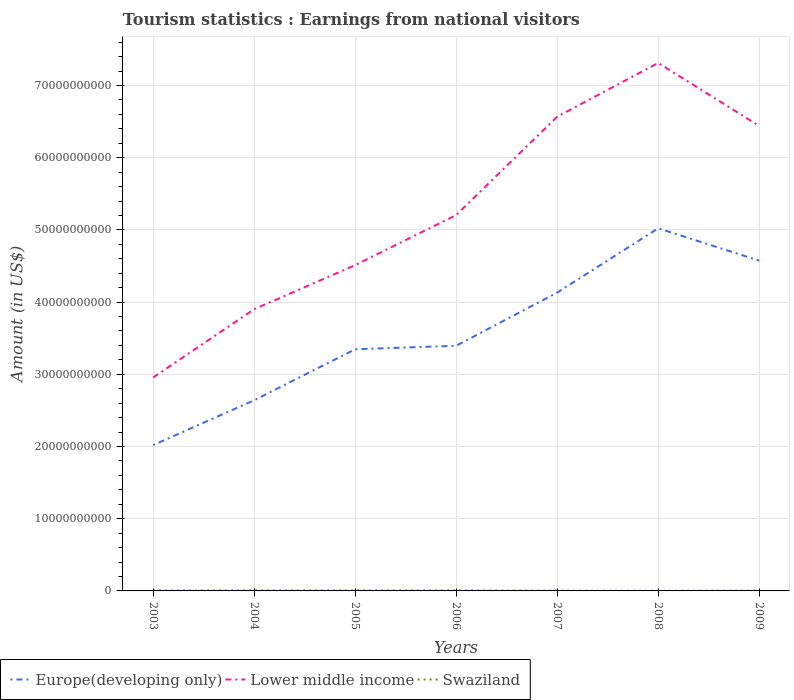Is the number of lines equal to the number of legend labels?
Ensure brevity in your answer.  Yes. Across all years, what is the maximum earnings from national visitors in Lower middle income?
Your answer should be very brief. 2.96e+1. What is the total earnings from national visitors in Lower middle income in the graph?
Offer a terse response. -2.67e+1. What is the difference between the highest and the second highest earnings from national visitors in Swaziland?
Give a very brief answer. 5.10e+07. What is the difference between the highest and the lowest earnings from national visitors in Lower middle income?
Provide a short and direct response. 3. Is the earnings from national visitors in Swaziland strictly greater than the earnings from national visitors in Europe(developing only) over the years?
Your answer should be very brief. Yes. How many years are there in the graph?
Provide a short and direct response. 7. What is the difference between two consecutive major ticks on the Y-axis?
Your response must be concise. 1.00e+1. Are the values on the major ticks of Y-axis written in scientific E-notation?
Your answer should be compact. No. How are the legend labels stacked?
Give a very brief answer. Horizontal. What is the title of the graph?
Provide a succinct answer. Tourism statistics : Earnings from national visitors. What is the label or title of the Y-axis?
Offer a terse response. Amount (in US$). What is the Amount (in US$) in Europe(developing only) in 2003?
Provide a succinct answer. 2.02e+1. What is the Amount (in US$) in Lower middle income in 2003?
Give a very brief answer. 2.96e+1. What is the Amount (in US$) in Swaziland in 2003?
Ensure brevity in your answer.  7.00e+07. What is the Amount (in US$) in Europe(developing only) in 2004?
Keep it short and to the point. 2.64e+1. What is the Amount (in US$) of Lower middle income in 2004?
Provide a short and direct response. 3.90e+1. What is the Amount (in US$) of Swaziland in 2004?
Ensure brevity in your answer.  7.51e+07. What is the Amount (in US$) of Europe(developing only) in 2005?
Make the answer very short. 3.35e+1. What is the Amount (in US$) of Lower middle income in 2005?
Keep it short and to the point. 4.51e+1. What is the Amount (in US$) of Swaziland in 2005?
Your response must be concise. 7.73e+07. What is the Amount (in US$) in Europe(developing only) in 2006?
Offer a very short reply. 3.40e+1. What is the Amount (in US$) of Lower middle income in 2006?
Ensure brevity in your answer.  5.21e+1. What is the Amount (in US$) in Swaziland in 2006?
Keep it short and to the point. 7.51e+07. What is the Amount (in US$) of Europe(developing only) in 2007?
Make the answer very short. 4.13e+1. What is the Amount (in US$) of Lower middle income in 2007?
Ensure brevity in your answer.  6.57e+1. What is the Amount (in US$) of Swaziland in 2007?
Offer a very short reply. 3.22e+07. What is the Amount (in US$) of Europe(developing only) in 2008?
Offer a terse response. 5.02e+1. What is the Amount (in US$) of Lower middle income in 2008?
Provide a short and direct response. 7.31e+1. What is the Amount (in US$) of Swaziland in 2008?
Provide a short and direct response. 2.63e+07. What is the Amount (in US$) in Europe(developing only) in 2009?
Keep it short and to the point. 4.57e+1. What is the Amount (in US$) of Lower middle income in 2009?
Offer a very short reply. 6.44e+1. What is the Amount (in US$) in Swaziland in 2009?
Your answer should be very brief. 4.01e+07. Across all years, what is the maximum Amount (in US$) in Europe(developing only)?
Ensure brevity in your answer.  5.02e+1. Across all years, what is the maximum Amount (in US$) of Lower middle income?
Ensure brevity in your answer.  7.31e+1. Across all years, what is the maximum Amount (in US$) in Swaziland?
Your response must be concise. 7.73e+07. Across all years, what is the minimum Amount (in US$) in Europe(developing only)?
Your answer should be very brief. 2.02e+1. Across all years, what is the minimum Amount (in US$) of Lower middle income?
Give a very brief answer. 2.96e+1. Across all years, what is the minimum Amount (in US$) in Swaziland?
Your answer should be very brief. 2.63e+07. What is the total Amount (in US$) of Europe(developing only) in the graph?
Make the answer very short. 2.51e+11. What is the total Amount (in US$) in Lower middle income in the graph?
Provide a short and direct response. 3.69e+11. What is the total Amount (in US$) of Swaziland in the graph?
Offer a very short reply. 3.96e+08. What is the difference between the Amount (in US$) of Europe(developing only) in 2003 and that in 2004?
Offer a very short reply. -6.21e+09. What is the difference between the Amount (in US$) in Lower middle income in 2003 and that in 2004?
Keep it short and to the point. -9.46e+09. What is the difference between the Amount (in US$) in Swaziland in 2003 and that in 2004?
Your answer should be compact. -5.06e+06. What is the difference between the Amount (in US$) of Europe(developing only) in 2003 and that in 2005?
Ensure brevity in your answer.  -1.33e+1. What is the difference between the Amount (in US$) of Lower middle income in 2003 and that in 2005?
Ensure brevity in your answer.  -1.56e+1. What is the difference between the Amount (in US$) in Swaziland in 2003 and that in 2005?
Offer a terse response. -7.26e+06. What is the difference between the Amount (in US$) in Europe(developing only) in 2003 and that in 2006?
Provide a succinct answer. -1.38e+1. What is the difference between the Amount (in US$) of Lower middle income in 2003 and that in 2006?
Provide a short and direct response. -2.25e+1. What is the difference between the Amount (in US$) in Swaziland in 2003 and that in 2006?
Make the answer very short. -5.06e+06. What is the difference between the Amount (in US$) of Europe(developing only) in 2003 and that in 2007?
Provide a short and direct response. -2.11e+1. What is the difference between the Amount (in US$) in Lower middle income in 2003 and that in 2007?
Your response must be concise. -3.61e+1. What is the difference between the Amount (in US$) in Swaziland in 2003 and that in 2007?
Your answer should be very brief. 3.78e+07. What is the difference between the Amount (in US$) of Europe(developing only) in 2003 and that in 2008?
Your response must be concise. -3.00e+1. What is the difference between the Amount (in US$) of Lower middle income in 2003 and that in 2008?
Your answer should be compact. -4.36e+1. What is the difference between the Amount (in US$) of Swaziland in 2003 and that in 2008?
Your answer should be very brief. 4.37e+07. What is the difference between the Amount (in US$) in Europe(developing only) in 2003 and that in 2009?
Keep it short and to the point. -2.55e+1. What is the difference between the Amount (in US$) of Lower middle income in 2003 and that in 2009?
Your response must be concise. -3.48e+1. What is the difference between the Amount (in US$) in Swaziland in 2003 and that in 2009?
Ensure brevity in your answer.  2.99e+07. What is the difference between the Amount (in US$) of Europe(developing only) in 2004 and that in 2005?
Offer a very short reply. -7.06e+09. What is the difference between the Amount (in US$) in Lower middle income in 2004 and that in 2005?
Offer a terse response. -6.11e+09. What is the difference between the Amount (in US$) of Swaziland in 2004 and that in 2005?
Provide a succinct answer. -2.20e+06. What is the difference between the Amount (in US$) of Europe(developing only) in 2004 and that in 2006?
Offer a terse response. -7.55e+09. What is the difference between the Amount (in US$) of Lower middle income in 2004 and that in 2006?
Your answer should be very brief. -1.30e+1. What is the difference between the Amount (in US$) in Europe(developing only) in 2004 and that in 2007?
Your response must be concise. -1.49e+1. What is the difference between the Amount (in US$) in Lower middle income in 2004 and that in 2007?
Your response must be concise. -2.67e+1. What is the difference between the Amount (in US$) of Swaziland in 2004 and that in 2007?
Provide a short and direct response. 4.29e+07. What is the difference between the Amount (in US$) of Europe(developing only) in 2004 and that in 2008?
Give a very brief answer. -2.38e+1. What is the difference between the Amount (in US$) of Lower middle income in 2004 and that in 2008?
Make the answer very short. -3.41e+1. What is the difference between the Amount (in US$) of Swaziland in 2004 and that in 2008?
Give a very brief answer. 4.88e+07. What is the difference between the Amount (in US$) in Europe(developing only) in 2004 and that in 2009?
Offer a terse response. -1.93e+1. What is the difference between the Amount (in US$) in Lower middle income in 2004 and that in 2009?
Your answer should be compact. -2.54e+1. What is the difference between the Amount (in US$) of Swaziland in 2004 and that in 2009?
Your answer should be very brief. 3.50e+07. What is the difference between the Amount (in US$) in Europe(developing only) in 2005 and that in 2006?
Ensure brevity in your answer.  -4.89e+08. What is the difference between the Amount (in US$) in Lower middle income in 2005 and that in 2006?
Provide a short and direct response. -6.93e+09. What is the difference between the Amount (in US$) of Swaziland in 2005 and that in 2006?
Provide a succinct answer. 2.20e+06. What is the difference between the Amount (in US$) of Europe(developing only) in 2005 and that in 2007?
Ensure brevity in your answer.  -7.85e+09. What is the difference between the Amount (in US$) in Lower middle income in 2005 and that in 2007?
Your answer should be very brief. -2.06e+1. What is the difference between the Amount (in US$) in Swaziland in 2005 and that in 2007?
Make the answer very short. 4.51e+07. What is the difference between the Amount (in US$) in Europe(developing only) in 2005 and that in 2008?
Your answer should be very brief. -1.68e+1. What is the difference between the Amount (in US$) of Lower middle income in 2005 and that in 2008?
Your answer should be compact. -2.80e+1. What is the difference between the Amount (in US$) in Swaziland in 2005 and that in 2008?
Ensure brevity in your answer.  5.10e+07. What is the difference between the Amount (in US$) of Europe(developing only) in 2005 and that in 2009?
Offer a very short reply. -1.23e+1. What is the difference between the Amount (in US$) in Lower middle income in 2005 and that in 2009?
Keep it short and to the point. -1.93e+1. What is the difference between the Amount (in US$) of Swaziland in 2005 and that in 2009?
Keep it short and to the point. 3.72e+07. What is the difference between the Amount (in US$) in Europe(developing only) in 2006 and that in 2007?
Your answer should be compact. -7.36e+09. What is the difference between the Amount (in US$) of Lower middle income in 2006 and that in 2007?
Make the answer very short. -1.36e+1. What is the difference between the Amount (in US$) of Swaziland in 2006 and that in 2007?
Your response must be concise. 4.29e+07. What is the difference between the Amount (in US$) of Europe(developing only) in 2006 and that in 2008?
Ensure brevity in your answer.  -1.63e+1. What is the difference between the Amount (in US$) in Lower middle income in 2006 and that in 2008?
Keep it short and to the point. -2.11e+1. What is the difference between the Amount (in US$) in Swaziland in 2006 and that in 2008?
Provide a succinct answer. 4.88e+07. What is the difference between the Amount (in US$) in Europe(developing only) in 2006 and that in 2009?
Offer a very short reply. -1.18e+1. What is the difference between the Amount (in US$) of Lower middle income in 2006 and that in 2009?
Make the answer very short. -1.23e+1. What is the difference between the Amount (in US$) in Swaziland in 2006 and that in 2009?
Your answer should be compact. 3.50e+07. What is the difference between the Amount (in US$) of Europe(developing only) in 2007 and that in 2008?
Provide a short and direct response. -8.91e+09. What is the difference between the Amount (in US$) of Lower middle income in 2007 and that in 2008?
Provide a short and direct response. -7.44e+09. What is the difference between the Amount (in US$) of Swaziland in 2007 and that in 2008?
Provide a succinct answer. 5.90e+06. What is the difference between the Amount (in US$) in Europe(developing only) in 2007 and that in 2009?
Offer a terse response. -4.43e+09. What is the difference between the Amount (in US$) of Lower middle income in 2007 and that in 2009?
Ensure brevity in your answer.  1.28e+09. What is the difference between the Amount (in US$) of Swaziland in 2007 and that in 2009?
Your response must be concise. -7.90e+06. What is the difference between the Amount (in US$) in Europe(developing only) in 2008 and that in 2009?
Keep it short and to the point. 4.48e+09. What is the difference between the Amount (in US$) in Lower middle income in 2008 and that in 2009?
Keep it short and to the point. 8.72e+09. What is the difference between the Amount (in US$) in Swaziland in 2008 and that in 2009?
Provide a succinct answer. -1.38e+07. What is the difference between the Amount (in US$) in Europe(developing only) in 2003 and the Amount (in US$) in Lower middle income in 2004?
Your response must be concise. -1.88e+1. What is the difference between the Amount (in US$) of Europe(developing only) in 2003 and the Amount (in US$) of Swaziland in 2004?
Offer a terse response. 2.01e+1. What is the difference between the Amount (in US$) of Lower middle income in 2003 and the Amount (in US$) of Swaziland in 2004?
Provide a succinct answer. 2.95e+1. What is the difference between the Amount (in US$) in Europe(developing only) in 2003 and the Amount (in US$) in Lower middle income in 2005?
Make the answer very short. -2.49e+1. What is the difference between the Amount (in US$) of Europe(developing only) in 2003 and the Amount (in US$) of Swaziland in 2005?
Offer a terse response. 2.01e+1. What is the difference between the Amount (in US$) of Lower middle income in 2003 and the Amount (in US$) of Swaziland in 2005?
Give a very brief answer. 2.95e+1. What is the difference between the Amount (in US$) in Europe(developing only) in 2003 and the Amount (in US$) in Lower middle income in 2006?
Keep it short and to the point. -3.19e+1. What is the difference between the Amount (in US$) in Europe(developing only) in 2003 and the Amount (in US$) in Swaziland in 2006?
Make the answer very short. 2.01e+1. What is the difference between the Amount (in US$) of Lower middle income in 2003 and the Amount (in US$) of Swaziland in 2006?
Provide a short and direct response. 2.95e+1. What is the difference between the Amount (in US$) of Europe(developing only) in 2003 and the Amount (in US$) of Lower middle income in 2007?
Ensure brevity in your answer.  -4.55e+1. What is the difference between the Amount (in US$) in Europe(developing only) in 2003 and the Amount (in US$) in Swaziland in 2007?
Your response must be concise. 2.02e+1. What is the difference between the Amount (in US$) of Lower middle income in 2003 and the Amount (in US$) of Swaziland in 2007?
Offer a very short reply. 2.95e+1. What is the difference between the Amount (in US$) of Europe(developing only) in 2003 and the Amount (in US$) of Lower middle income in 2008?
Your answer should be compact. -5.29e+1. What is the difference between the Amount (in US$) of Europe(developing only) in 2003 and the Amount (in US$) of Swaziland in 2008?
Your answer should be compact. 2.02e+1. What is the difference between the Amount (in US$) of Lower middle income in 2003 and the Amount (in US$) of Swaziland in 2008?
Offer a terse response. 2.95e+1. What is the difference between the Amount (in US$) of Europe(developing only) in 2003 and the Amount (in US$) of Lower middle income in 2009?
Ensure brevity in your answer.  -4.42e+1. What is the difference between the Amount (in US$) of Europe(developing only) in 2003 and the Amount (in US$) of Swaziland in 2009?
Your answer should be compact. 2.02e+1. What is the difference between the Amount (in US$) of Lower middle income in 2003 and the Amount (in US$) of Swaziland in 2009?
Your response must be concise. 2.95e+1. What is the difference between the Amount (in US$) in Europe(developing only) in 2004 and the Amount (in US$) in Lower middle income in 2005?
Your response must be concise. -1.87e+1. What is the difference between the Amount (in US$) of Europe(developing only) in 2004 and the Amount (in US$) of Swaziland in 2005?
Make the answer very short. 2.63e+1. What is the difference between the Amount (in US$) in Lower middle income in 2004 and the Amount (in US$) in Swaziland in 2005?
Give a very brief answer. 3.89e+1. What is the difference between the Amount (in US$) in Europe(developing only) in 2004 and the Amount (in US$) in Lower middle income in 2006?
Your answer should be compact. -2.56e+1. What is the difference between the Amount (in US$) of Europe(developing only) in 2004 and the Amount (in US$) of Swaziland in 2006?
Offer a very short reply. 2.63e+1. What is the difference between the Amount (in US$) of Lower middle income in 2004 and the Amount (in US$) of Swaziland in 2006?
Your response must be concise. 3.89e+1. What is the difference between the Amount (in US$) in Europe(developing only) in 2004 and the Amount (in US$) in Lower middle income in 2007?
Keep it short and to the point. -3.93e+1. What is the difference between the Amount (in US$) of Europe(developing only) in 2004 and the Amount (in US$) of Swaziland in 2007?
Ensure brevity in your answer.  2.64e+1. What is the difference between the Amount (in US$) in Lower middle income in 2004 and the Amount (in US$) in Swaziland in 2007?
Offer a very short reply. 3.90e+1. What is the difference between the Amount (in US$) of Europe(developing only) in 2004 and the Amount (in US$) of Lower middle income in 2008?
Your response must be concise. -4.67e+1. What is the difference between the Amount (in US$) of Europe(developing only) in 2004 and the Amount (in US$) of Swaziland in 2008?
Provide a succinct answer. 2.64e+1. What is the difference between the Amount (in US$) of Lower middle income in 2004 and the Amount (in US$) of Swaziland in 2008?
Keep it short and to the point. 3.90e+1. What is the difference between the Amount (in US$) in Europe(developing only) in 2004 and the Amount (in US$) in Lower middle income in 2009?
Give a very brief answer. -3.80e+1. What is the difference between the Amount (in US$) of Europe(developing only) in 2004 and the Amount (in US$) of Swaziland in 2009?
Ensure brevity in your answer.  2.64e+1. What is the difference between the Amount (in US$) of Lower middle income in 2004 and the Amount (in US$) of Swaziland in 2009?
Keep it short and to the point. 3.90e+1. What is the difference between the Amount (in US$) of Europe(developing only) in 2005 and the Amount (in US$) of Lower middle income in 2006?
Your answer should be very brief. -1.86e+1. What is the difference between the Amount (in US$) of Europe(developing only) in 2005 and the Amount (in US$) of Swaziland in 2006?
Provide a short and direct response. 3.34e+1. What is the difference between the Amount (in US$) of Lower middle income in 2005 and the Amount (in US$) of Swaziland in 2006?
Keep it short and to the point. 4.50e+1. What is the difference between the Amount (in US$) in Europe(developing only) in 2005 and the Amount (in US$) in Lower middle income in 2007?
Give a very brief answer. -3.22e+1. What is the difference between the Amount (in US$) of Europe(developing only) in 2005 and the Amount (in US$) of Swaziland in 2007?
Offer a very short reply. 3.34e+1. What is the difference between the Amount (in US$) in Lower middle income in 2005 and the Amount (in US$) in Swaziland in 2007?
Your answer should be compact. 4.51e+1. What is the difference between the Amount (in US$) in Europe(developing only) in 2005 and the Amount (in US$) in Lower middle income in 2008?
Give a very brief answer. -3.97e+1. What is the difference between the Amount (in US$) in Europe(developing only) in 2005 and the Amount (in US$) in Swaziland in 2008?
Your response must be concise. 3.34e+1. What is the difference between the Amount (in US$) in Lower middle income in 2005 and the Amount (in US$) in Swaziland in 2008?
Offer a terse response. 4.51e+1. What is the difference between the Amount (in US$) of Europe(developing only) in 2005 and the Amount (in US$) of Lower middle income in 2009?
Ensure brevity in your answer.  -3.09e+1. What is the difference between the Amount (in US$) of Europe(developing only) in 2005 and the Amount (in US$) of Swaziland in 2009?
Your answer should be very brief. 3.34e+1. What is the difference between the Amount (in US$) of Lower middle income in 2005 and the Amount (in US$) of Swaziland in 2009?
Make the answer very short. 4.51e+1. What is the difference between the Amount (in US$) of Europe(developing only) in 2006 and the Amount (in US$) of Lower middle income in 2007?
Your answer should be very brief. -3.17e+1. What is the difference between the Amount (in US$) in Europe(developing only) in 2006 and the Amount (in US$) in Swaziland in 2007?
Offer a terse response. 3.39e+1. What is the difference between the Amount (in US$) in Lower middle income in 2006 and the Amount (in US$) in Swaziland in 2007?
Your answer should be very brief. 5.20e+1. What is the difference between the Amount (in US$) of Europe(developing only) in 2006 and the Amount (in US$) of Lower middle income in 2008?
Your answer should be compact. -3.92e+1. What is the difference between the Amount (in US$) of Europe(developing only) in 2006 and the Amount (in US$) of Swaziland in 2008?
Make the answer very short. 3.39e+1. What is the difference between the Amount (in US$) in Lower middle income in 2006 and the Amount (in US$) in Swaziland in 2008?
Provide a succinct answer. 5.20e+1. What is the difference between the Amount (in US$) of Europe(developing only) in 2006 and the Amount (in US$) of Lower middle income in 2009?
Ensure brevity in your answer.  -3.04e+1. What is the difference between the Amount (in US$) in Europe(developing only) in 2006 and the Amount (in US$) in Swaziland in 2009?
Your response must be concise. 3.39e+1. What is the difference between the Amount (in US$) of Lower middle income in 2006 and the Amount (in US$) of Swaziland in 2009?
Provide a short and direct response. 5.20e+1. What is the difference between the Amount (in US$) of Europe(developing only) in 2007 and the Amount (in US$) of Lower middle income in 2008?
Offer a terse response. -3.18e+1. What is the difference between the Amount (in US$) in Europe(developing only) in 2007 and the Amount (in US$) in Swaziland in 2008?
Provide a succinct answer. 4.13e+1. What is the difference between the Amount (in US$) in Lower middle income in 2007 and the Amount (in US$) in Swaziland in 2008?
Provide a short and direct response. 6.57e+1. What is the difference between the Amount (in US$) in Europe(developing only) in 2007 and the Amount (in US$) in Lower middle income in 2009?
Provide a short and direct response. -2.31e+1. What is the difference between the Amount (in US$) of Europe(developing only) in 2007 and the Amount (in US$) of Swaziland in 2009?
Make the answer very short. 4.13e+1. What is the difference between the Amount (in US$) of Lower middle income in 2007 and the Amount (in US$) of Swaziland in 2009?
Offer a terse response. 6.56e+1. What is the difference between the Amount (in US$) in Europe(developing only) in 2008 and the Amount (in US$) in Lower middle income in 2009?
Your response must be concise. -1.42e+1. What is the difference between the Amount (in US$) in Europe(developing only) in 2008 and the Amount (in US$) in Swaziland in 2009?
Your response must be concise. 5.02e+1. What is the difference between the Amount (in US$) in Lower middle income in 2008 and the Amount (in US$) in Swaziland in 2009?
Ensure brevity in your answer.  7.31e+1. What is the average Amount (in US$) in Europe(developing only) per year?
Make the answer very short. 3.59e+1. What is the average Amount (in US$) in Lower middle income per year?
Your answer should be compact. 5.27e+1. What is the average Amount (in US$) in Swaziland per year?
Keep it short and to the point. 5.66e+07. In the year 2003, what is the difference between the Amount (in US$) in Europe(developing only) and Amount (in US$) in Lower middle income?
Your answer should be very brief. -9.36e+09. In the year 2003, what is the difference between the Amount (in US$) of Europe(developing only) and Amount (in US$) of Swaziland?
Provide a short and direct response. 2.01e+1. In the year 2003, what is the difference between the Amount (in US$) in Lower middle income and Amount (in US$) in Swaziland?
Make the answer very short. 2.95e+1. In the year 2004, what is the difference between the Amount (in US$) in Europe(developing only) and Amount (in US$) in Lower middle income?
Your answer should be very brief. -1.26e+1. In the year 2004, what is the difference between the Amount (in US$) of Europe(developing only) and Amount (in US$) of Swaziland?
Keep it short and to the point. 2.63e+1. In the year 2004, what is the difference between the Amount (in US$) of Lower middle income and Amount (in US$) of Swaziland?
Provide a short and direct response. 3.89e+1. In the year 2005, what is the difference between the Amount (in US$) in Europe(developing only) and Amount (in US$) in Lower middle income?
Provide a short and direct response. -1.17e+1. In the year 2005, what is the difference between the Amount (in US$) of Europe(developing only) and Amount (in US$) of Swaziland?
Give a very brief answer. 3.34e+1. In the year 2005, what is the difference between the Amount (in US$) in Lower middle income and Amount (in US$) in Swaziland?
Offer a terse response. 4.50e+1. In the year 2006, what is the difference between the Amount (in US$) in Europe(developing only) and Amount (in US$) in Lower middle income?
Give a very brief answer. -1.81e+1. In the year 2006, what is the difference between the Amount (in US$) of Europe(developing only) and Amount (in US$) of Swaziland?
Offer a terse response. 3.39e+1. In the year 2006, what is the difference between the Amount (in US$) in Lower middle income and Amount (in US$) in Swaziland?
Offer a very short reply. 5.20e+1. In the year 2007, what is the difference between the Amount (in US$) in Europe(developing only) and Amount (in US$) in Lower middle income?
Your response must be concise. -2.44e+1. In the year 2007, what is the difference between the Amount (in US$) in Europe(developing only) and Amount (in US$) in Swaziland?
Your answer should be compact. 4.13e+1. In the year 2007, what is the difference between the Amount (in US$) of Lower middle income and Amount (in US$) of Swaziland?
Provide a succinct answer. 6.56e+1. In the year 2008, what is the difference between the Amount (in US$) of Europe(developing only) and Amount (in US$) of Lower middle income?
Offer a terse response. -2.29e+1. In the year 2008, what is the difference between the Amount (in US$) of Europe(developing only) and Amount (in US$) of Swaziland?
Give a very brief answer. 5.02e+1. In the year 2008, what is the difference between the Amount (in US$) in Lower middle income and Amount (in US$) in Swaziland?
Make the answer very short. 7.31e+1. In the year 2009, what is the difference between the Amount (in US$) of Europe(developing only) and Amount (in US$) of Lower middle income?
Make the answer very short. -1.87e+1. In the year 2009, what is the difference between the Amount (in US$) in Europe(developing only) and Amount (in US$) in Swaziland?
Your response must be concise. 4.57e+1. In the year 2009, what is the difference between the Amount (in US$) in Lower middle income and Amount (in US$) in Swaziland?
Make the answer very short. 6.44e+1. What is the ratio of the Amount (in US$) of Europe(developing only) in 2003 to that in 2004?
Your response must be concise. 0.76. What is the ratio of the Amount (in US$) in Lower middle income in 2003 to that in 2004?
Offer a terse response. 0.76. What is the ratio of the Amount (in US$) of Swaziland in 2003 to that in 2004?
Keep it short and to the point. 0.93. What is the ratio of the Amount (in US$) of Europe(developing only) in 2003 to that in 2005?
Make the answer very short. 0.6. What is the ratio of the Amount (in US$) of Lower middle income in 2003 to that in 2005?
Provide a succinct answer. 0.66. What is the ratio of the Amount (in US$) in Swaziland in 2003 to that in 2005?
Keep it short and to the point. 0.91. What is the ratio of the Amount (in US$) in Europe(developing only) in 2003 to that in 2006?
Your answer should be compact. 0.59. What is the ratio of the Amount (in US$) in Lower middle income in 2003 to that in 2006?
Offer a terse response. 0.57. What is the ratio of the Amount (in US$) of Swaziland in 2003 to that in 2006?
Keep it short and to the point. 0.93. What is the ratio of the Amount (in US$) of Europe(developing only) in 2003 to that in 2007?
Provide a succinct answer. 0.49. What is the ratio of the Amount (in US$) of Lower middle income in 2003 to that in 2007?
Your response must be concise. 0.45. What is the ratio of the Amount (in US$) in Swaziland in 2003 to that in 2007?
Provide a succinct answer. 2.18. What is the ratio of the Amount (in US$) in Europe(developing only) in 2003 to that in 2008?
Ensure brevity in your answer.  0.4. What is the ratio of the Amount (in US$) of Lower middle income in 2003 to that in 2008?
Ensure brevity in your answer.  0.4. What is the ratio of the Amount (in US$) in Swaziland in 2003 to that in 2008?
Offer a terse response. 2.66. What is the ratio of the Amount (in US$) in Europe(developing only) in 2003 to that in 2009?
Your response must be concise. 0.44. What is the ratio of the Amount (in US$) of Lower middle income in 2003 to that in 2009?
Your response must be concise. 0.46. What is the ratio of the Amount (in US$) of Swaziland in 2003 to that in 2009?
Your answer should be very brief. 1.75. What is the ratio of the Amount (in US$) in Europe(developing only) in 2004 to that in 2005?
Your answer should be compact. 0.79. What is the ratio of the Amount (in US$) of Lower middle income in 2004 to that in 2005?
Provide a succinct answer. 0.86. What is the ratio of the Amount (in US$) of Swaziland in 2004 to that in 2005?
Offer a terse response. 0.97. What is the ratio of the Amount (in US$) of Europe(developing only) in 2004 to that in 2006?
Offer a terse response. 0.78. What is the ratio of the Amount (in US$) in Lower middle income in 2004 to that in 2006?
Your answer should be compact. 0.75. What is the ratio of the Amount (in US$) in Swaziland in 2004 to that in 2006?
Your answer should be compact. 1. What is the ratio of the Amount (in US$) in Europe(developing only) in 2004 to that in 2007?
Give a very brief answer. 0.64. What is the ratio of the Amount (in US$) in Lower middle income in 2004 to that in 2007?
Provide a succinct answer. 0.59. What is the ratio of the Amount (in US$) in Swaziland in 2004 to that in 2007?
Keep it short and to the point. 2.33. What is the ratio of the Amount (in US$) of Europe(developing only) in 2004 to that in 2008?
Provide a succinct answer. 0.53. What is the ratio of the Amount (in US$) in Lower middle income in 2004 to that in 2008?
Ensure brevity in your answer.  0.53. What is the ratio of the Amount (in US$) of Swaziland in 2004 to that in 2008?
Ensure brevity in your answer.  2.86. What is the ratio of the Amount (in US$) in Europe(developing only) in 2004 to that in 2009?
Your response must be concise. 0.58. What is the ratio of the Amount (in US$) of Lower middle income in 2004 to that in 2009?
Keep it short and to the point. 0.61. What is the ratio of the Amount (in US$) in Swaziland in 2004 to that in 2009?
Keep it short and to the point. 1.87. What is the ratio of the Amount (in US$) of Europe(developing only) in 2005 to that in 2006?
Your response must be concise. 0.99. What is the ratio of the Amount (in US$) in Lower middle income in 2005 to that in 2006?
Provide a short and direct response. 0.87. What is the ratio of the Amount (in US$) of Swaziland in 2005 to that in 2006?
Provide a succinct answer. 1.03. What is the ratio of the Amount (in US$) in Europe(developing only) in 2005 to that in 2007?
Your response must be concise. 0.81. What is the ratio of the Amount (in US$) of Lower middle income in 2005 to that in 2007?
Provide a short and direct response. 0.69. What is the ratio of the Amount (in US$) of Swaziland in 2005 to that in 2007?
Offer a terse response. 2.4. What is the ratio of the Amount (in US$) in Europe(developing only) in 2005 to that in 2008?
Provide a short and direct response. 0.67. What is the ratio of the Amount (in US$) in Lower middle income in 2005 to that in 2008?
Provide a short and direct response. 0.62. What is the ratio of the Amount (in US$) of Swaziland in 2005 to that in 2008?
Your answer should be very brief. 2.94. What is the ratio of the Amount (in US$) of Europe(developing only) in 2005 to that in 2009?
Keep it short and to the point. 0.73. What is the ratio of the Amount (in US$) in Lower middle income in 2005 to that in 2009?
Ensure brevity in your answer.  0.7. What is the ratio of the Amount (in US$) in Swaziland in 2005 to that in 2009?
Provide a short and direct response. 1.93. What is the ratio of the Amount (in US$) of Europe(developing only) in 2006 to that in 2007?
Provide a succinct answer. 0.82. What is the ratio of the Amount (in US$) in Lower middle income in 2006 to that in 2007?
Provide a succinct answer. 0.79. What is the ratio of the Amount (in US$) of Swaziland in 2006 to that in 2007?
Provide a succinct answer. 2.33. What is the ratio of the Amount (in US$) of Europe(developing only) in 2006 to that in 2008?
Offer a terse response. 0.68. What is the ratio of the Amount (in US$) in Lower middle income in 2006 to that in 2008?
Give a very brief answer. 0.71. What is the ratio of the Amount (in US$) of Swaziland in 2006 to that in 2008?
Offer a very short reply. 2.86. What is the ratio of the Amount (in US$) of Europe(developing only) in 2006 to that in 2009?
Make the answer very short. 0.74. What is the ratio of the Amount (in US$) in Lower middle income in 2006 to that in 2009?
Give a very brief answer. 0.81. What is the ratio of the Amount (in US$) of Swaziland in 2006 to that in 2009?
Give a very brief answer. 1.87. What is the ratio of the Amount (in US$) of Europe(developing only) in 2007 to that in 2008?
Give a very brief answer. 0.82. What is the ratio of the Amount (in US$) in Lower middle income in 2007 to that in 2008?
Offer a terse response. 0.9. What is the ratio of the Amount (in US$) of Swaziland in 2007 to that in 2008?
Your answer should be compact. 1.22. What is the ratio of the Amount (in US$) of Europe(developing only) in 2007 to that in 2009?
Provide a short and direct response. 0.9. What is the ratio of the Amount (in US$) in Lower middle income in 2007 to that in 2009?
Your response must be concise. 1.02. What is the ratio of the Amount (in US$) in Swaziland in 2007 to that in 2009?
Your answer should be very brief. 0.8. What is the ratio of the Amount (in US$) in Europe(developing only) in 2008 to that in 2009?
Your response must be concise. 1.1. What is the ratio of the Amount (in US$) in Lower middle income in 2008 to that in 2009?
Your answer should be very brief. 1.14. What is the ratio of the Amount (in US$) of Swaziland in 2008 to that in 2009?
Keep it short and to the point. 0.66. What is the difference between the highest and the second highest Amount (in US$) of Europe(developing only)?
Offer a very short reply. 4.48e+09. What is the difference between the highest and the second highest Amount (in US$) of Lower middle income?
Provide a succinct answer. 7.44e+09. What is the difference between the highest and the second highest Amount (in US$) in Swaziland?
Provide a succinct answer. 2.20e+06. What is the difference between the highest and the lowest Amount (in US$) in Europe(developing only)?
Your answer should be compact. 3.00e+1. What is the difference between the highest and the lowest Amount (in US$) of Lower middle income?
Keep it short and to the point. 4.36e+1. What is the difference between the highest and the lowest Amount (in US$) of Swaziland?
Give a very brief answer. 5.10e+07. 